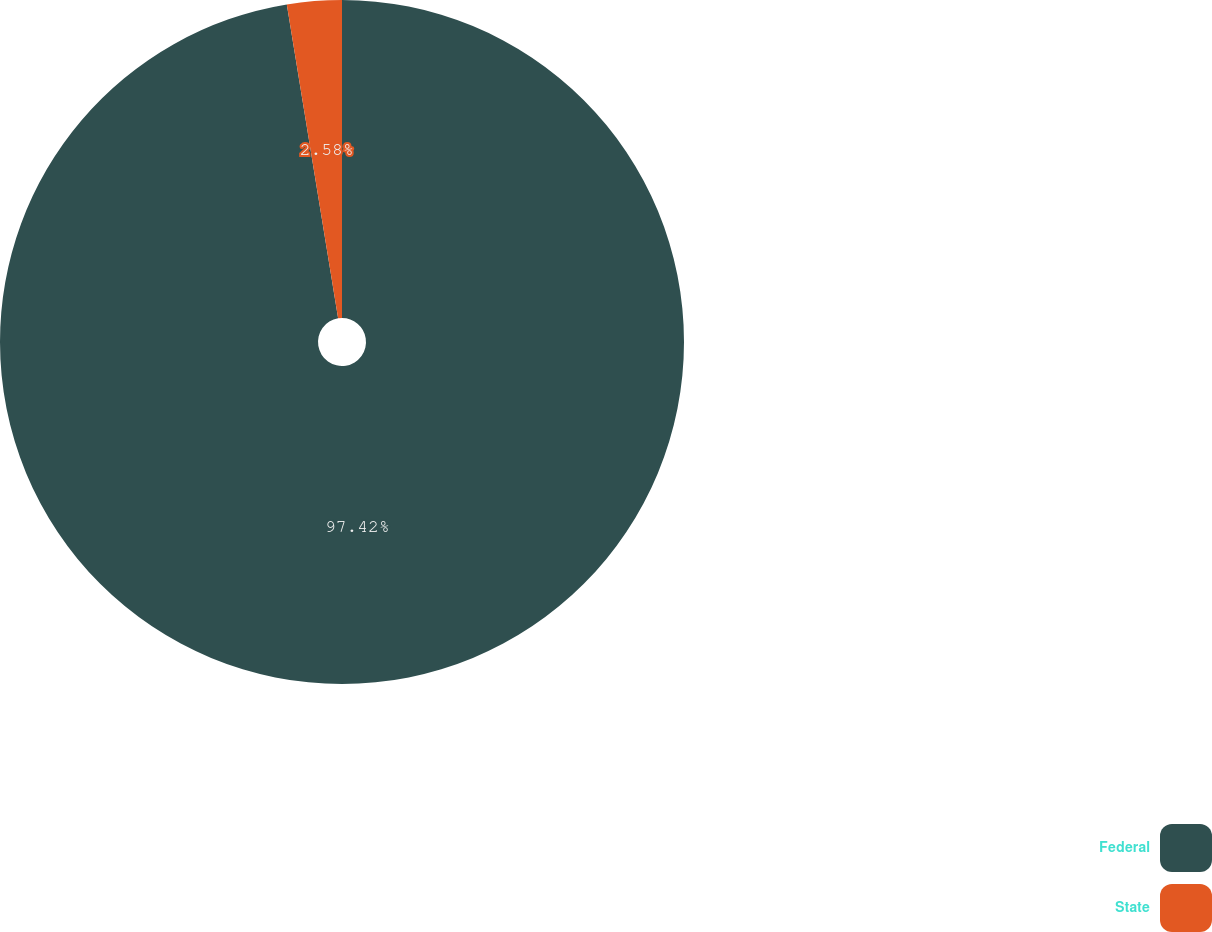<chart> <loc_0><loc_0><loc_500><loc_500><pie_chart><fcel>Federal<fcel>State<nl><fcel>97.42%<fcel>2.58%<nl></chart> 